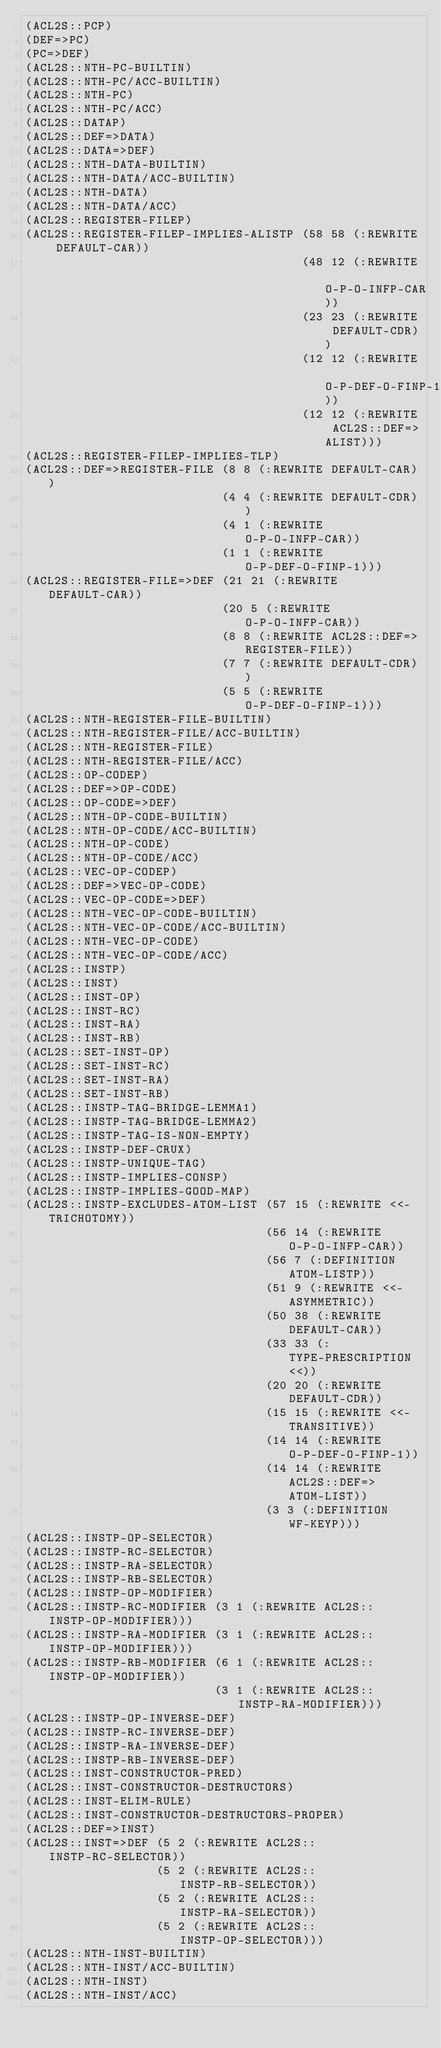Convert code to text. <code><loc_0><loc_0><loc_500><loc_500><_Lisp_>(ACL2S::PCP)
(DEF=>PC)
(PC=>DEF)
(ACL2S::NTH-PC-BUILTIN)
(ACL2S::NTH-PC/ACC-BUILTIN)
(ACL2S::NTH-PC)
(ACL2S::NTH-PC/ACC)
(ACL2S::DATAP)
(ACL2S::DEF=>DATA)
(ACL2S::DATA=>DEF)
(ACL2S::NTH-DATA-BUILTIN)
(ACL2S::NTH-DATA/ACC-BUILTIN)
(ACL2S::NTH-DATA)
(ACL2S::NTH-DATA/ACC)
(ACL2S::REGISTER-FILEP)
(ACL2S::REGISTER-FILEP-IMPLIES-ALISTP (58 58 (:REWRITE DEFAULT-CAR))
                                      (48 12 (:REWRITE O-P-O-INFP-CAR))
                                      (23 23 (:REWRITE DEFAULT-CDR))
                                      (12 12 (:REWRITE O-P-DEF-O-FINP-1))
                                      (12 12 (:REWRITE ACL2S::DEF=>ALIST)))
(ACL2S::REGISTER-FILEP-IMPLIES-TLP)
(ACL2S::DEF=>REGISTER-FILE (8 8 (:REWRITE DEFAULT-CAR))
                           (4 4 (:REWRITE DEFAULT-CDR))
                           (4 1 (:REWRITE O-P-O-INFP-CAR))
                           (1 1 (:REWRITE O-P-DEF-O-FINP-1)))
(ACL2S::REGISTER-FILE=>DEF (21 21 (:REWRITE DEFAULT-CAR))
                           (20 5 (:REWRITE O-P-O-INFP-CAR))
                           (8 8 (:REWRITE ACL2S::DEF=>REGISTER-FILE))
                           (7 7 (:REWRITE DEFAULT-CDR))
                           (5 5 (:REWRITE O-P-DEF-O-FINP-1)))
(ACL2S::NTH-REGISTER-FILE-BUILTIN)
(ACL2S::NTH-REGISTER-FILE/ACC-BUILTIN)
(ACL2S::NTH-REGISTER-FILE)
(ACL2S::NTH-REGISTER-FILE/ACC)
(ACL2S::OP-CODEP)
(ACL2S::DEF=>OP-CODE)
(ACL2S::OP-CODE=>DEF)
(ACL2S::NTH-OP-CODE-BUILTIN)
(ACL2S::NTH-OP-CODE/ACC-BUILTIN)
(ACL2S::NTH-OP-CODE)
(ACL2S::NTH-OP-CODE/ACC)
(ACL2S::VEC-OP-CODEP)
(ACL2S::DEF=>VEC-OP-CODE)
(ACL2S::VEC-OP-CODE=>DEF)
(ACL2S::NTH-VEC-OP-CODE-BUILTIN)
(ACL2S::NTH-VEC-OP-CODE/ACC-BUILTIN)
(ACL2S::NTH-VEC-OP-CODE)
(ACL2S::NTH-VEC-OP-CODE/ACC)
(ACL2S::INSTP)
(ACL2S::INST)
(ACL2S::INST-OP)
(ACL2S::INST-RC)
(ACL2S::INST-RA)
(ACL2S::INST-RB)
(ACL2S::SET-INST-OP)
(ACL2S::SET-INST-RC)
(ACL2S::SET-INST-RA)
(ACL2S::SET-INST-RB)
(ACL2S::INSTP-TAG-BRIDGE-LEMMA1)
(ACL2S::INSTP-TAG-BRIDGE-LEMMA2)
(ACL2S::INSTP-TAG-IS-NON-EMPTY)
(ACL2S::INSTP-DEF-CRUX)
(ACL2S::INSTP-UNIQUE-TAG)
(ACL2S::INSTP-IMPLIES-CONSP)
(ACL2S::INSTP-IMPLIES-GOOD-MAP)
(ACL2S::INSTP-EXCLUDES-ATOM-LIST (57 15 (:REWRITE <<-TRICHOTOMY))
                                 (56 14 (:REWRITE O-P-O-INFP-CAR))
                                 (56 7 (:DEFINITION ATOM-LISTP))
                                 (51 9 (:REWRITE <<-ASYMMETRIC))
                                 (50 38 (:REWRITE DEFAULT-CAR))
                                 (33 33 (:TYPE-PRESCRIPTION <<))
                                 (20 20 (:REWRITE DEFAULT-CDR))
                                 (15 15 (:REWRITE <<-TRANSITIVE))
                                 (14 14 (:REWRITE O-P-DEF-O-FINP-1))
                                 (14 14 (:REWRITE ACL2S::DEF=>ATOM-LIST))
                                 (3 3 (:DEFINITION WF-KEYP)))
(ACL2S::INSTP-OP-SELECTOR)
(ACL2S::INSTP-RC-SELECTOR)
(ACL2S::INSTP-RA-SELECTOR)
(ACL2S::INSTP-RB-SELECTOR)
(ACL2S::INSTP-OP-MODIFIER)
(ACL2S::INSTP-RC-MODIFIER (3 1 (:REWRITE ACL2S::INSTP-OP-MODIFIER)))
(ACL2S::INSTP-RA-MODIFIER (3 1 (:REWRITE ACL2S::INSTP-OP-MODIFIER)))
(ACL2S::INSTP-RB-MODIFIER (6 1 (:REWRITE ACL2S::INSTP-OP-MODIFIER))
                          (3 1 (:REWRITE ACL2S::INSTP-RA-MODIFIER)))
(ACL2S::INSTP-OP-INVERSE-DEF)
(ACL2S::INSTP-RC-INVERSE-DEF)
(ACL2S::INSTP-RA-INVERSE-DEF)
(ACL2S::INSTP-RB-INVERSE-DEF)
(ACL2S::INST-CONSTRUCTOR-PRED)
(ACL2S::INST-CONSTRUCTOR-DESTRUCTORS)
(ACL2S::INST-ELIM-RULE)
(ACL2S::INST-CONSTRUCTOR-DESTRUCTORS-PROPER)
(ACL2S::DEF=>INST)
(ACL2S::INST=>DEF (5 2 (:REWRITE ACL2S::INSTP-RC-SELECTOR))
                  (5 2 (:REWRITE ACL2S::INSTP-RB-SELECTOR))
                  (5 2 (:REWRITE ACL2S::INSTP-RA-SELECTOR))
                  (5 2 (:REWRITE ACL2S::INSTP-OP-SELECTOR)))
(ACL2S::NTH-INST-BUILTIN)
(ACL2S::NTH-INST/ACC-BUILTIN)
(ACL2S::NTH-INST)
(ACL2S::NTH-INST/ACC)</code> 